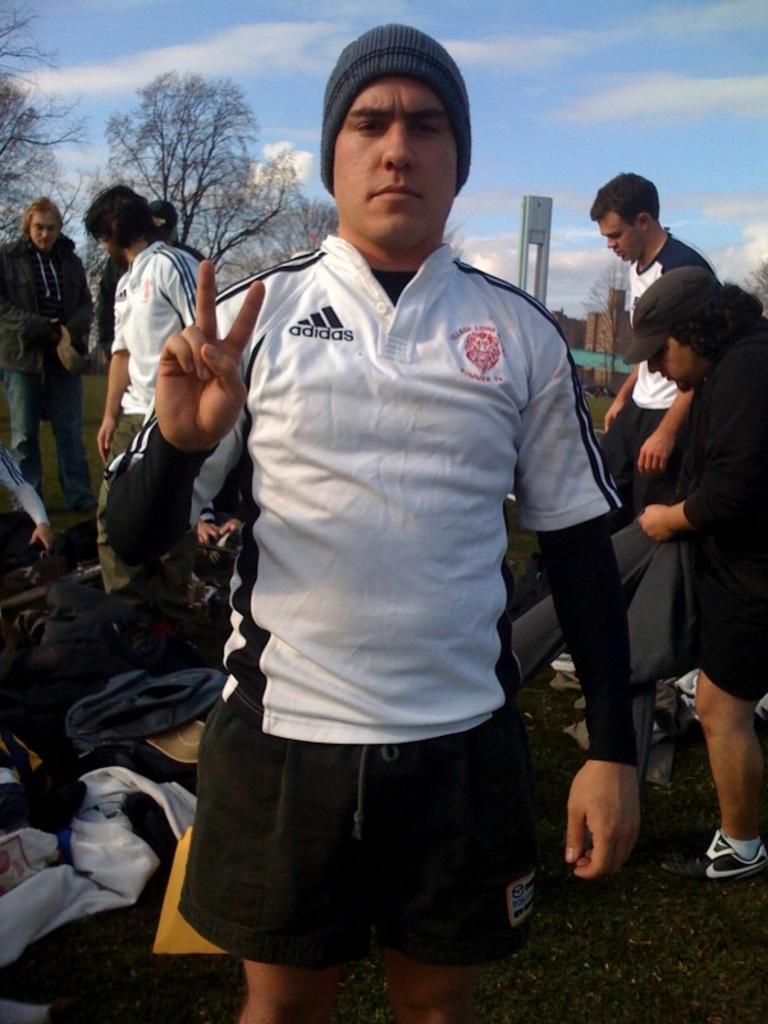What brand of shirt is he wearing?
Ensure brevity in your answer.  Adidas. 